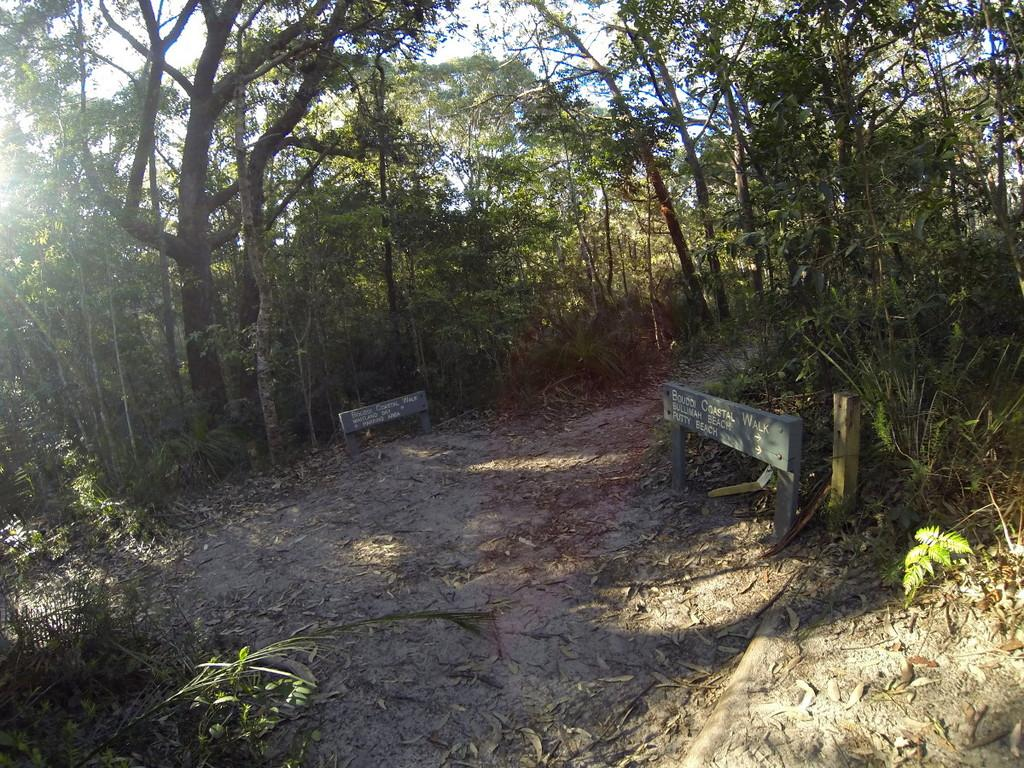What is the main feature in the center of the image? There is a mud road in the center of the image. What can be seen in the background of the image? There are trees in the background of the image. What type of religious symbol can be seen on the mud road in the image? There is no religious symbol present on the mud road in the image. What emotion is expressed by the mud road in the image? The mud road does not express any emotion; it is an inanimate object. 